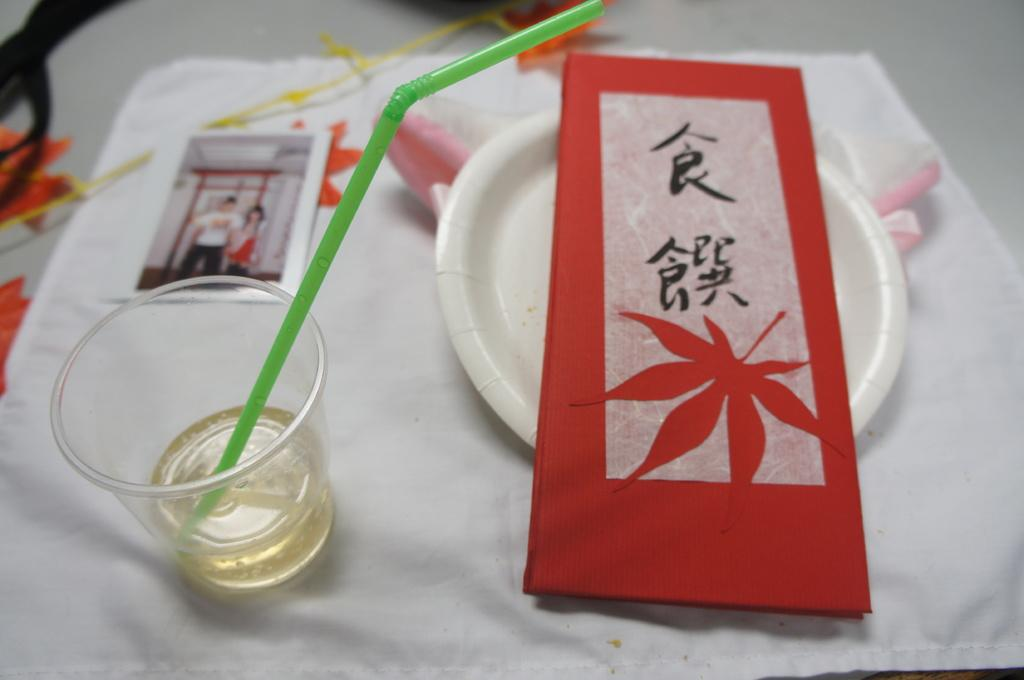What piece of furniture is present in the image? There is a table in the image. What is placed on the table? There is a plate on the table. What is on the plate? There is a glass on the plate. What is inside the glass? There is a straw in the glass. What else is on the plate? There is a card on the plate. How many men can be seen in the image? There are no men present in the image. What type of thunder can be heard in the background of the image? There is no thunder present in the image, as it is a still image without any sound. 